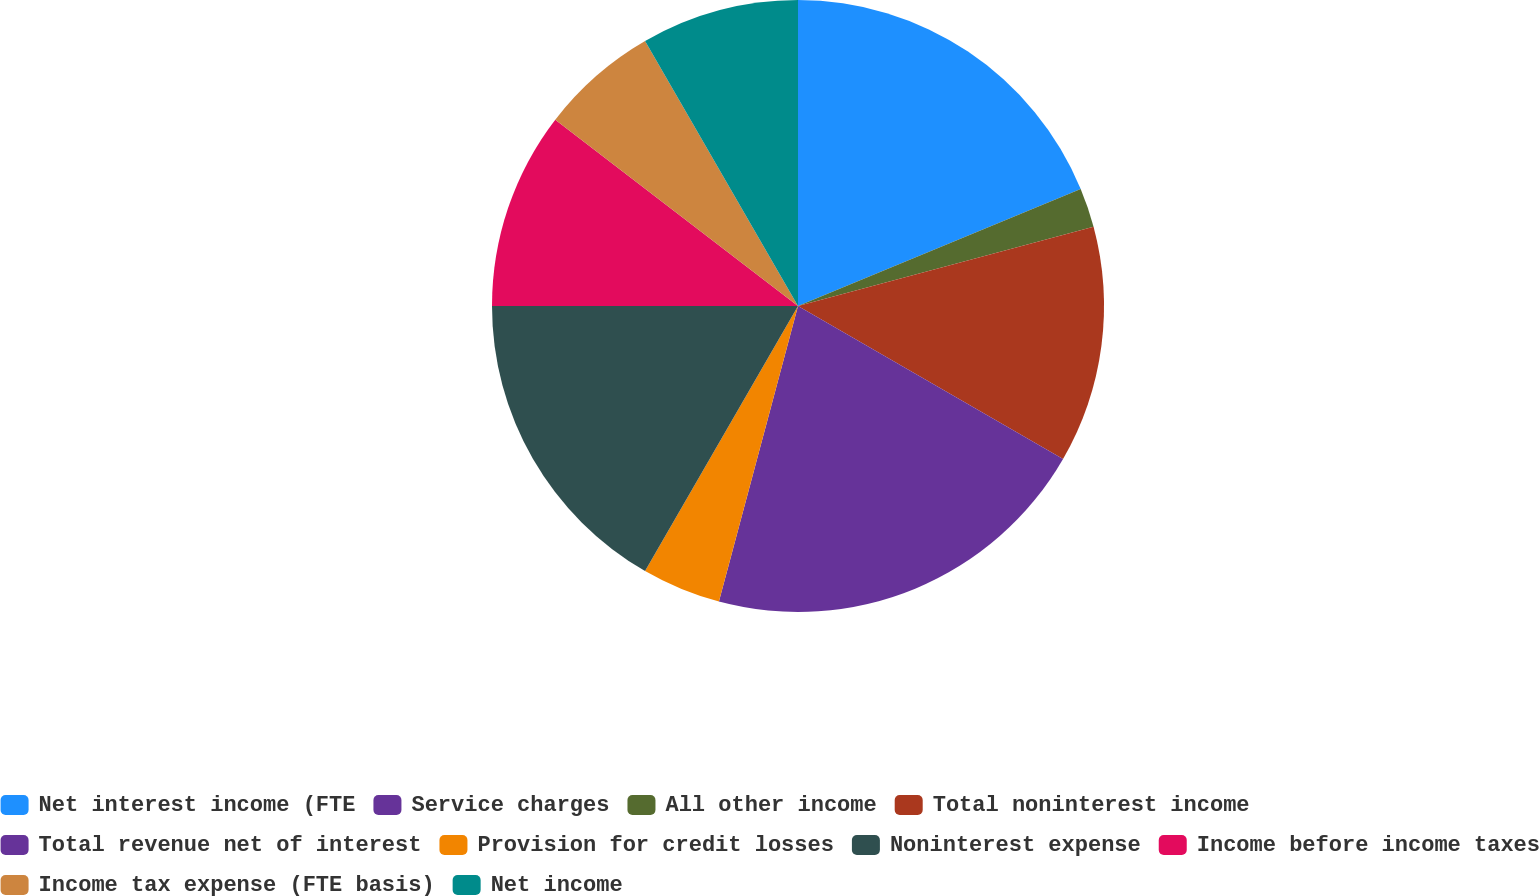<chart> <loc_0><loc_0><loc_500><loc_500><pie_chart><fcel>Net interest income (FTE<fcel>Service charges<fcel>All other income<fcel>Total noninterest income<fcel>Total revenue net of interest<fcel>Provision for credit losses<fcel>Noninterest expense<fcel>Income before income taxes<fcel>Income tax expense (FTE basis)<fcel>Net income<nl><fcel>18.75%<fcel>0.0%<fcel>2.08%<fcel>12.5%<fcel>20.83%<fcel>4.17%<fcel>16.67%<fcel>10.42%<fcel>6.25%<fcel>8.33%<nl></chart> 